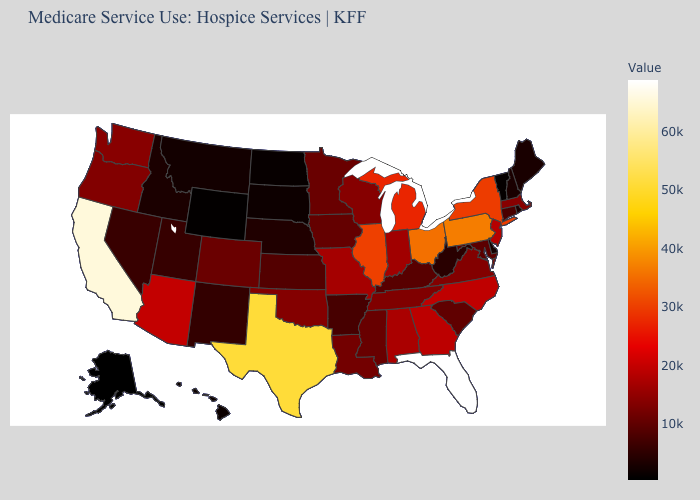Which states hav the highest value in the MidWest?
Write a very short answer. Ohio. Among the states that border New Hampshire , which have the lowest value?
Give a very brief answer. Vermont. Does Connecticut have a lower value than Alabama?
Write a very short answer. Yes. Does Wisconsin have the lowest value in the MidWest?
Answer briefly. No. Does South Carolina have a higher value than Alabama?
Keep it brief. No. Among the states that border Pennsylvania , does New Jersey have the lowest value?
Keep it brief. No. Among the states that border Kentucky , does Indiana have the highest value?
Keep it brief. No. 